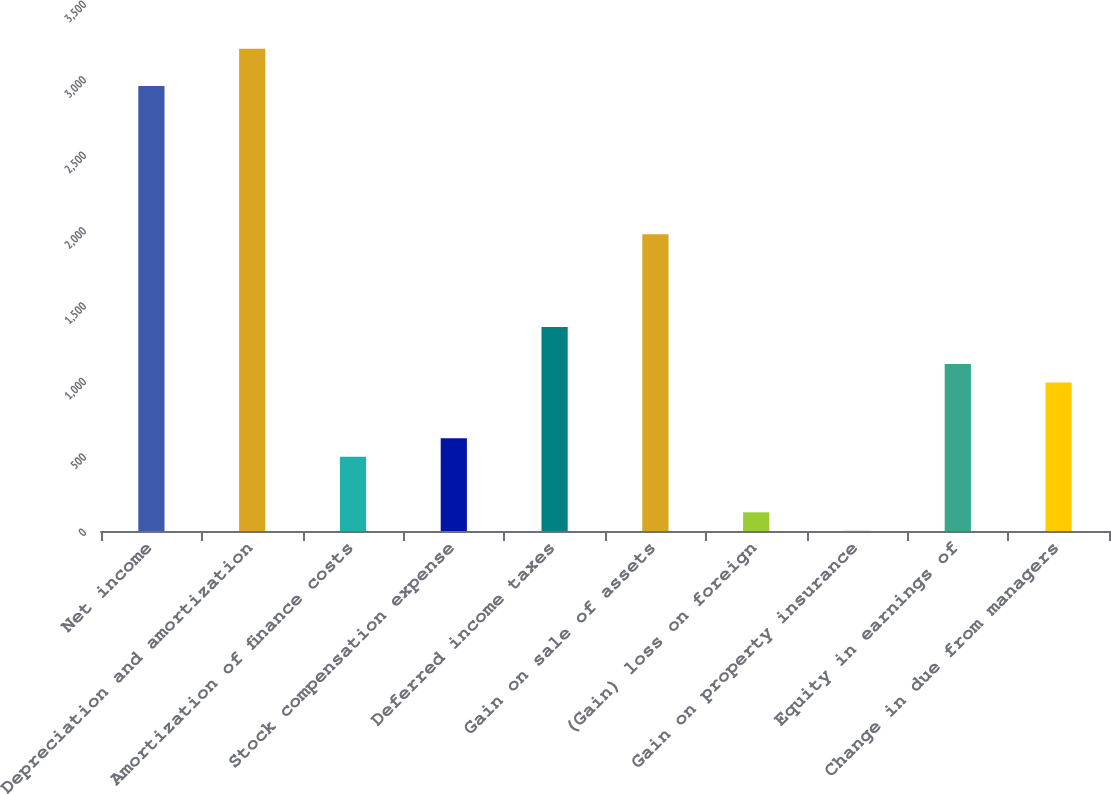<chart> <loc_0><loc_0><loc_500><loc_500><bar_chart><fcel>Net income<fcel>Depreciation and amortization<fcel>Amortization of finance costs<fcel>Stock compensation expense<fcel>Deferred income taxes<fcel>Gain on sale of assets<fcel>(Gain) loss on foreign<fcel>Gain on property insurance<fcel>Equity in earnings of<fcel>Change in due from managers<nl><fcel>2950.6<fcel>3196.4<fcel>492.6<fcel>615.5<fcel>1352.9<fcel>1967.4<fcel>123.9<fcel>1<fcel>1107.1<fcel>984.2<nl></chart> 